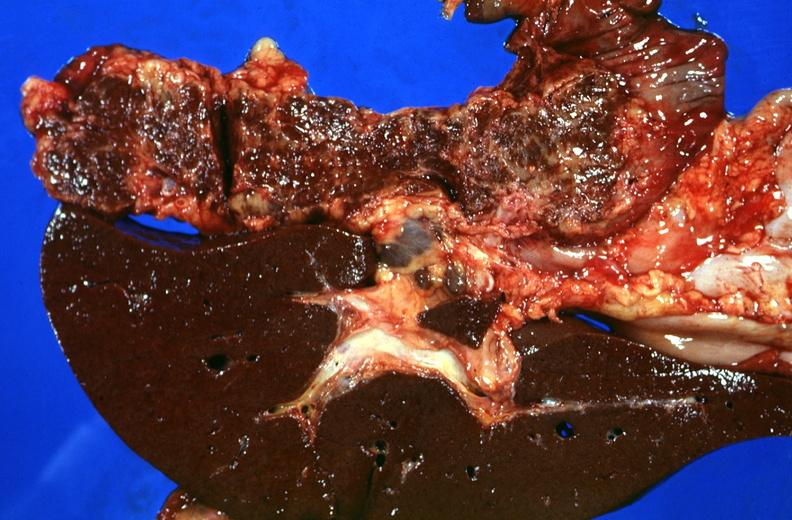what is present?
Answer the question using a single word or phrase. Hepatobiliary 